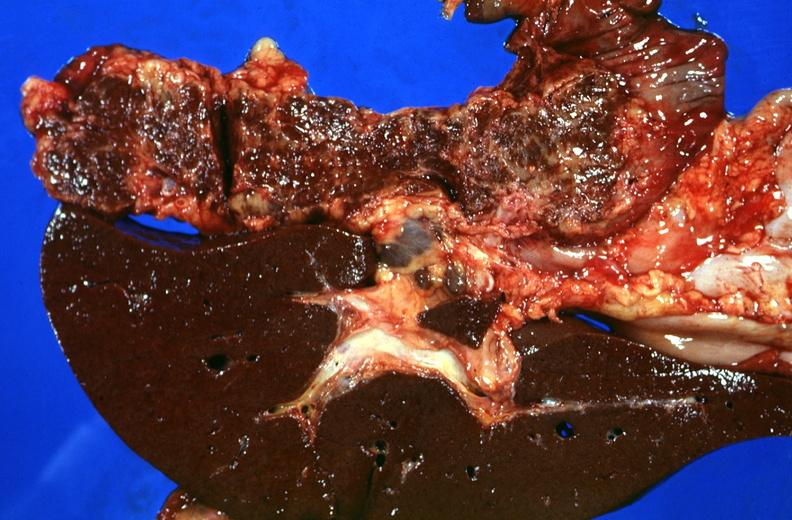what is present?
Answer the question using a single word or phrase. Hepatobiliary 